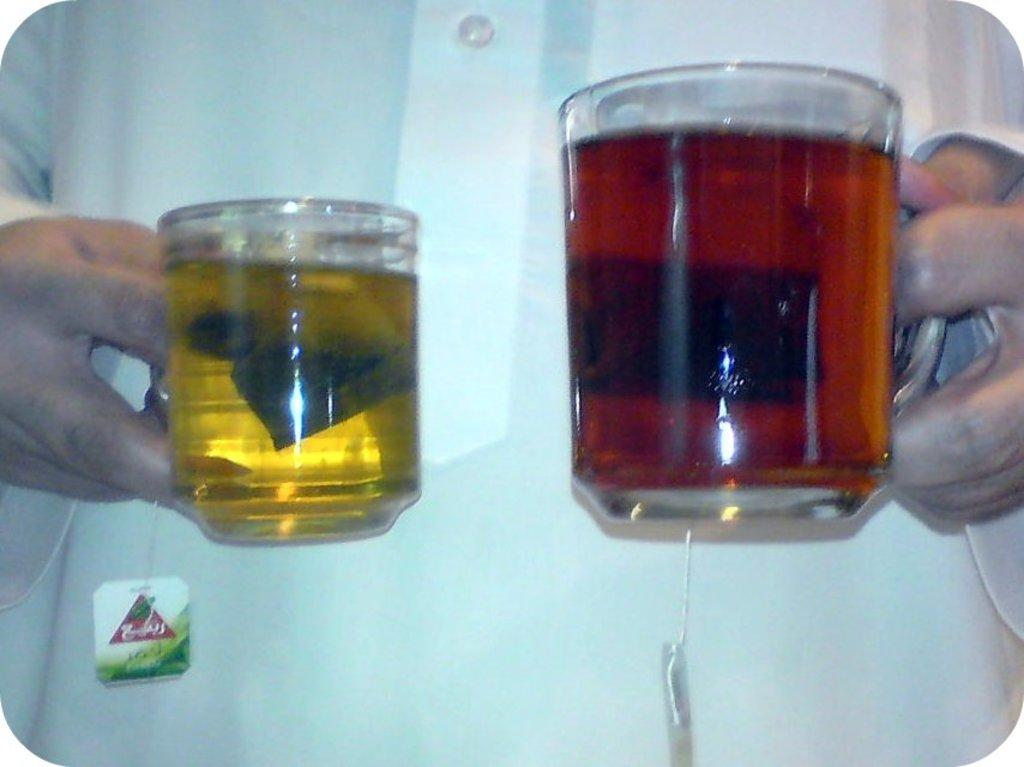What is the main subject of the image? There is a person in the image. What is the person holding in their hands? The person is holding two glasses in their hands. What type of bread can be seen in the image? There is no bread present in the image. Is there a cactus visible in the image? No, there is no cactus present in the image. 